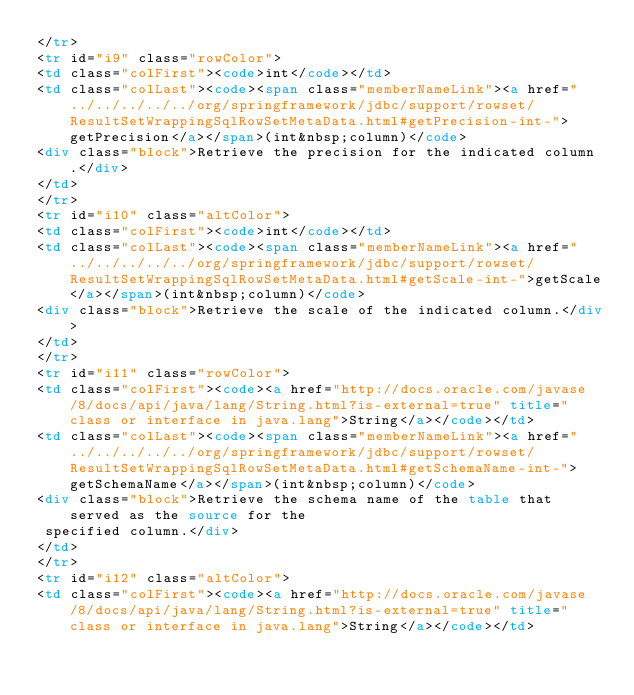<code> <loc_0><loc_0><loc_500><loc_500><_HTML_></tr>
<tr id="i9" class="rowColor">
<td class="colFirst"><code>int</code></td>
<td class="colLast"><code><span class="memberNameLink"><a href="../../../../../org/springframework/jdbc/support/rowset/ResultSetWrappingSqlRowSetMetaData.html#getPrecision-int-">getPrecision</a></span>(int&nbsp;column)</code>
<div class="block">Retrieve the precision for the indicated column.</div>
</td>
</tr>
<tr id="i10" class="altColor">
<td class="colFirst"><code>int</code></td>
<td class="colLast"><code><span class="memberNameLink"><a href="../../../../../org/springframework/jdbc/support/rowset/ResultSetWrappingSqlRowSetMetaData.html#getScale-int-">getScale</a></span>(int&nbsp;column)</code>
<div class="block">Retrieve the scale of the indicated column.</div>
</td>
</tr>
<tr id="i11" class="rowColor">
<td class="colFirst"><code><a href="http://docs.oracle.com/javase/8/docs/api/java/lang/String.html?is-external=true" title="class or interface in java.lang">String</a></code></td>
<td class="colLast"><code><span class="memberNameLink"><a href="../../../../../org/springframework/jdbc/support/rowset/ResultSetWrappingSqlRowSetMetaData.html#getSchemaName-int-">getSchemaName</a></span>(int&nbsp;column)</code>
<div class="block">Retrieve the schema name of the table that served as the source for the
 specified column.</div>
</td>
</tr>
<tr id="i12" class="altColor">
<td class="colFirst"><code><a href="http://docs.oracle.com/javase/8/docs/api/java/lang/String.html?is-external=true" title="class or interface in java.lang">String</a></code></td></code> 